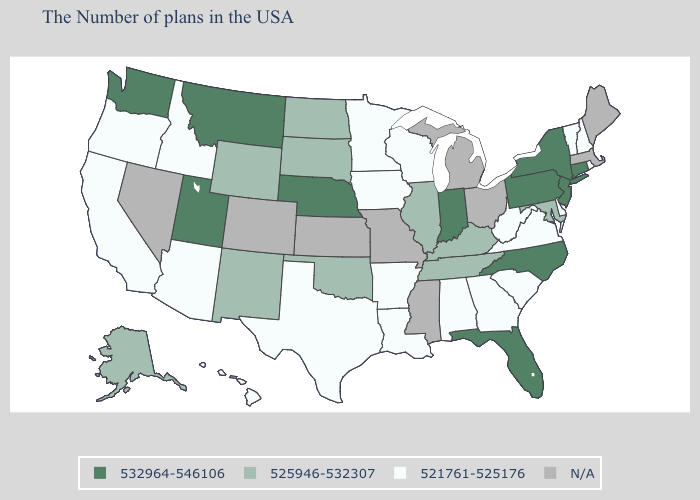What is the value of Texas?
Short answer required. 521761-525176. Does the map have missing data?
Give a very brief answer. Yes. Does New Hampshire have the highest value in the Northeast?
Short answer required. No. Name the states that have a value in the range 521761-525176?
Keep it brief. Rhode Island, New Hampshire, Vermont, Delaware, Virginia, South Carolina, West Virginia, Georgia, Alabama, Wisconsin, Louisiana, Arkansas, Minnesota, Iowa, Texas, Arizona, Idaho, California, Oregon, Hawaii. Which states have the highest value in the USA?
Short answer required. Connecticut, New York, New Jersey, Pennsylvania, North Carolina, Florida, Indiana, Nebraska, Utah, Montana, Washington. What is the value of Arizona?
Be succinct. 521761-525176. Name the states that have a value in the range N/A?
Answer briefly. Maine, Massachusetts, Ohio, Michigan, Mississippi, Missouri, Kansas, Colorado, Nevada. Name the states that have a value in the range 525946-532307?
Concise answer only. Maryland, Kentucky, Tennessee, Illinois, Oklahoma, South Dakota, North Dakota, Wyoming, New Mexico, Alaska. Name the states that have a value in the range N/A?
Be succinct. Maine, Massachusetts, Ohio, Michigan, Mississippi, Missouri, Kansas, Colorado, Nevada. What is the value of Kentucky?
Quick response, please. 525946-532307. What is the value of New York?
Keep it brief. 532964-546106. Name the states that have a value in the range 525946-532307?
Be succinct. Maryland, Kentucky, Tennessee, Illinois, Oklahoma, South Dakota, North Dakota, Wyoming, New Mexico, Alaska. What is the highest value in the USA?
Short answer required. 532964-546106. 